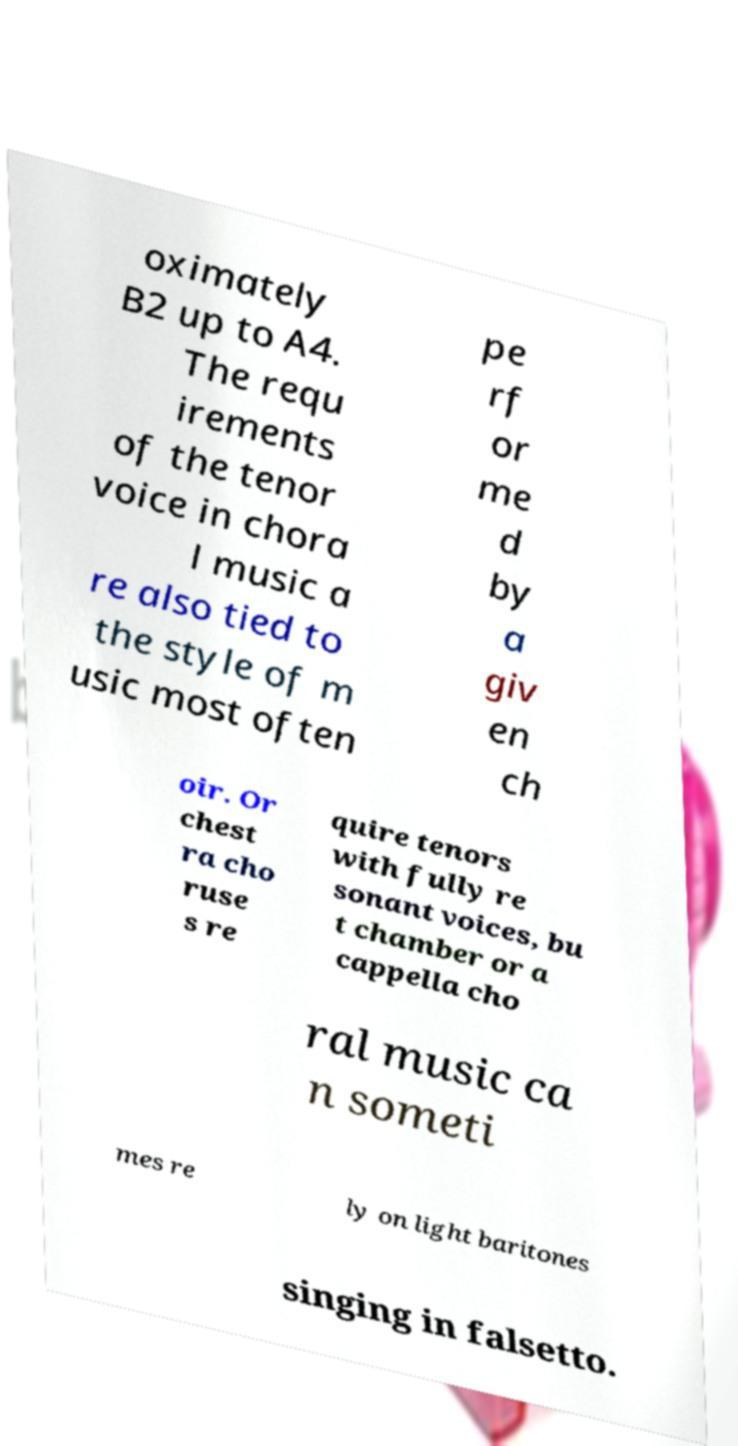Can you accurately transcribe the text from the provided image for me? oximately B2 up to A4. The requ irements of the tenor voice in chora l music a re also tied to the style of m usic most often pe rf or me d by a giv en ch oir. Or chest ra cho ruse s re quire tenors with fully re sonant voices, bu t chamber or a cappella cho ral music ca n someti mes re ly on light baritones singing in falsetto. 